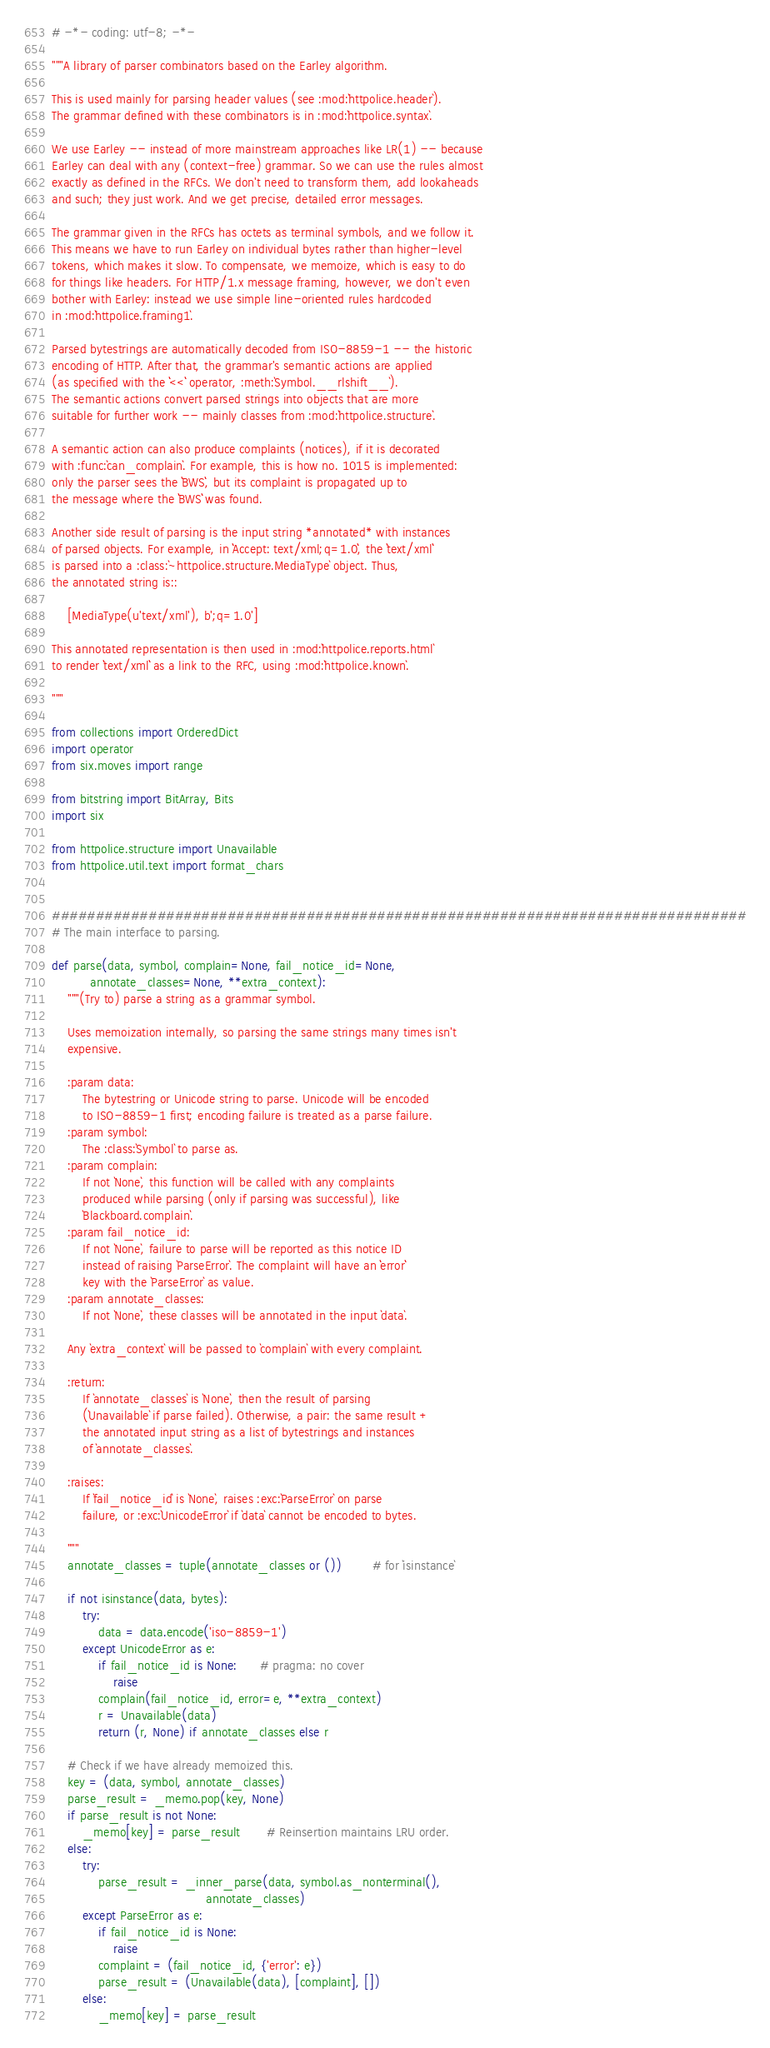Convert code to text. <code><loc_0><loc_0><loc_500><loc_500><_Python_># -*- coding: utf-8; -*-

"""A library of parser combinators based on the Earley algorithm.

This is used mainly for parsing header values (see :mod:`httpolice.header`).
The grammar defined with these combinators is in :mod:`httpolice.syntax`.

We use Earley -- instead of more mainstream approaches like LR(1) -- because
Earley can deal with any (context-free) grammar. So we can use the rules almost
exactly as defined in the RFCs. We don't need to transform them, add lookaheads
and such; they just work. And we get precise, detailed error messages.

The grammar given in the RFCs has octets as terminal symbols, and we follow it.
This means we have to run Earley on individual bytes rather than higher-level
tokens, which makes it slow. To compensate, we memoize, which is easy to do
for things like headers. For HTTP/1.x message framing, however, we don't even
bother with Earley: instead we use simple line-oriented rules hardcoded
in :mod:`httpolice.framing1`.

Parsed bytestrings are automatically decoded from ISO-8859-1 -- the historic
encoding of HTTP. After that, the grammar's semantic actions are applied
(as specified with the ``<<`` operator, :meth:`Symbol.__rlshift__`).
The semantic actions convert parsed strings into objects that are more
suitable for further work -- mainly classes from :mod:`httpolice.structure`.

A semantic action can also produce complaints (notices), if it is decorated
with :func:`can_complain`. For example, this is how no. 1015 is implemented:
only the parser sees the ``BWS``, but its complaint is propagated up to
the message where the ``BWS`` was found.

Another side result of parsing is the input string *annotated* with instances
of parsed objects. For example, in ``Accept: text/xml;q=1.0``, the ``text/xml``
is parsed into a :class:`~httpolice.structure.MediaType` object. Thus,
the annotated string is::

    [MediaType(u'text/xml'), b';q=1.0']

This annotated representation is then used in :mod:`httpolice.reports.html`
to render ``text/xml`` as a link to the RFC, using :mod:`httpolice.known`.

"""

from collections import OrderedDict
import operator
from six.moves import range

from bitstring import BitArray, Bits
import six

from httpolice.structure import Unavailable
from httpolice.util.text import format_chars


###############################################################################
# The main interface to parsing.

def parse(data, symbol, complain=None, fail_notice_id=None,
          annotate_classes=None, **extra_context):
    """(Try to) parse a string as a grammar symbol.

    Uses memoization internally, so parsing the same strings many times isn't
    expensive.

    :param data:
        The bytestring or Unicode string to parse. Unicode will be encoded
        to ISO-8859-1 first; encoding failure is treated as a parse failure.
    :param symbol:
        The :class:`Symbol` to parse as.
    :param complain:
        If not `None`, this function will be called with any complaints
        produced while parsing (only if parsing was successful), like
        `Blackboard.complain`.
    :param fail_notice_id:
        If not `None`, failure to parse will be reported as this notice ID
        instead of raising `ParseError`. The complaint will have an ``error``
        key with the `ParseError` as value.
    :param annotate_classes:
        If not `None`, these classes will be annotated in the input `data`.

    Any `extra_context` will be passed to `complain` with every complaint.

    :return:
        If `annotate_classes` is `None`, then the result of parsing
        (`Unavailable` if parse failed). Otherwise, a pair: the same result +
        the annotated input string as a list of bytestrings and instances
        of `annotate_classes`.

    :raises:
        If `fail_notice_id` is `None`, raises :exc:`ParseError` on parse
        failure, or :exc:`UnicodeError` if `data` cannot be encoded to bytes.

    """
    annotate_classes = tuple(annotate_classes or ())        # for `isinstance`

    if not isinstance(data, bytes):
        try:
            data = data.encode('iso-8859-1')
        except UnicodeError as e:
            if fail_notice_id is None:      # pragma: no cover
                raise
            complain(fail_notice_id, error=e, **extra_context)
            r = Unavailable(data)
            return (r, None) if annotate_classes else r

    # Check if we have already memoized this.
    key = (data, symbol, annotate_classes)
    parse_result = _memo.pop(key, None)
    if parse_result is not None:
        _memo[key] = parse_result       # Reinsertion maintains LRU order.
    else:
        try:
            parse_result = _inner_parse(data, symbol.as_nonterminal(),
                                        annotate_classes)
        except ParseError as e:
            if fail_notice_id is None:
                raise
            complaint = (fail_notice_id, {'error': e})
            parse_result = (Unavailable(data), [complaint], [])
        else:
            _memo[key] = parse_result</code> 